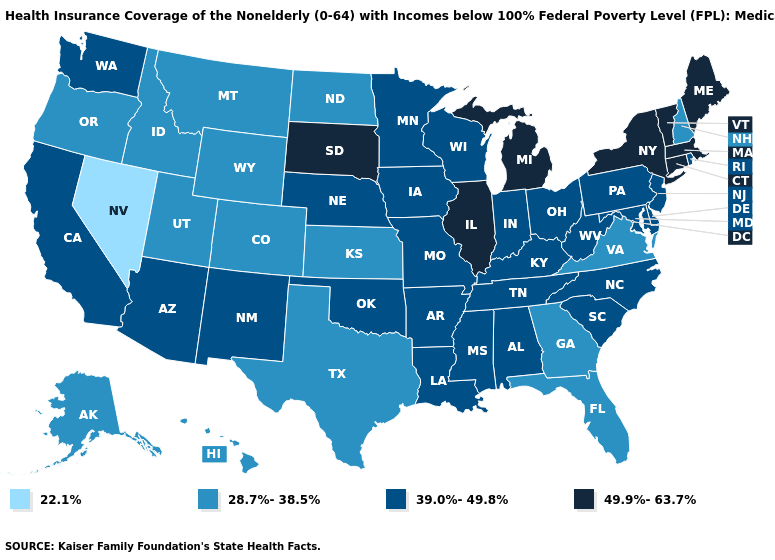Which states have the lowest value in the South?
Be succinct. Florida, Georgia, Texas, Virginia. Does Connecticut have a lower value than North Dakota?
Write a very short answer. No. Does Montana have the lowest value in the USA?
Keep it brief. No. Is the legend a continuous bar?
Short answer required. No. Does Tennessee have the same value as Arkansas?
Keep it brief. Yes. What is the lowest value in states that border Colorado?
Keep it brief. 28.7%-38.5%. Does Vermont have the highest value in the USA?
Quick response, please. Yes. What is the value of Missouri?
Concise answer only. 39.0%-49.8%. Does Texas have a higher value than Nevada?
Write a very short answer. Yes. Name the states that have a value in the range 28.7%-38.5%?
Give a very brief answer. Alaska, Colorado, Florida, Georgia, Hawaii, Idaho, Kansas, Montana, New Hampshire, North Dakota, Oregon, Texas, Utah, Virginia, Wyoming. Does Indiana have the highest value in the MidWest?
Give a very brief answer. No. Does Mississippi have the same value as Texas?
Answer briefly. No. Name the states that have a value in the range 28.7%-38.5%?
Be succinct. Alaska, Colorado, Florida, Georgia, Hawaii, Idaho, Kansas, Montana, New Hampshire, North Dakota, Oregon, Texas, Utah, Virginia, Wyoming. What is the value of Nevada?
Concise answer only. 22.1%. Which states have the lowest value in the Northeast?
Short answer required. New Hampshire. 